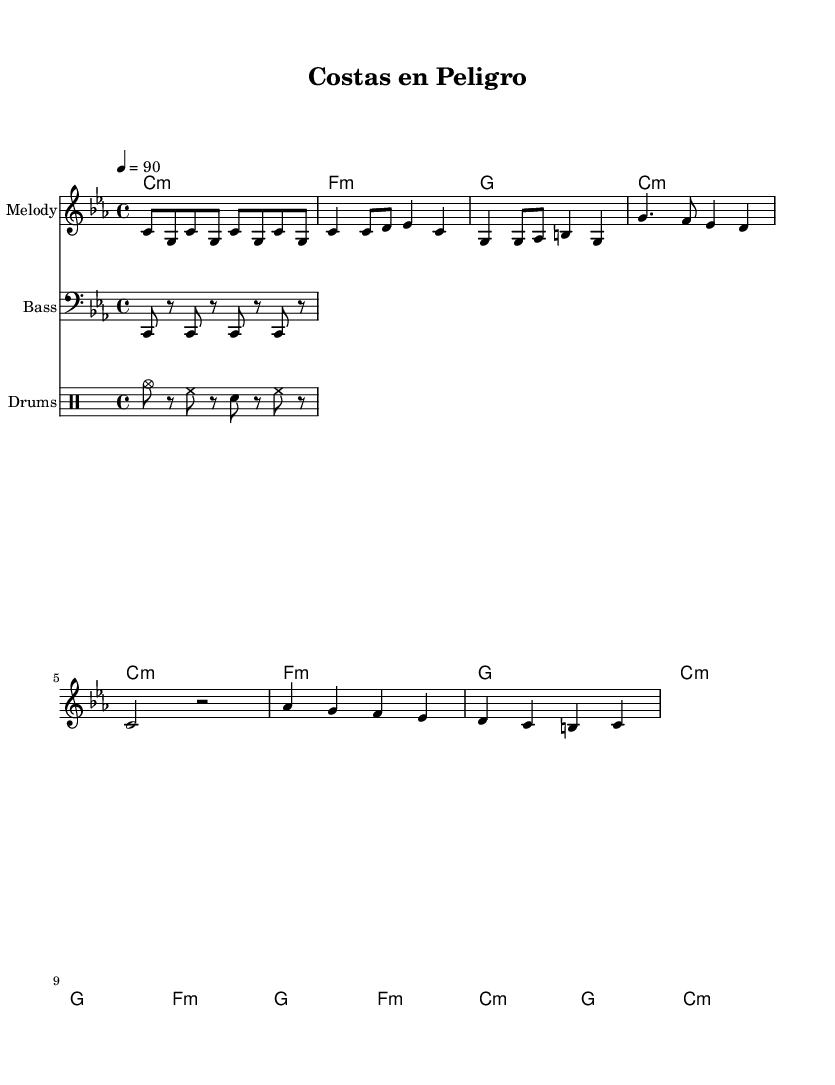What is the key signature of this music? The key signature is C minor, which includes three flats (B♭, E♭, and A♭). You can determine this by looking at the key signature at the beginning of the sheet music, which indicates the pitch and tonal center of the piece.
Answer: C minor What is the time signature of this music? The time signature is 4/4, as indicated at the beginning of the sheet music. This means there are four beats in each measure and the quarter note receives one beat.
Answer: 4/4 What is the tempo marking for this piece? The tempo marking is 90 beats per minute, which is indicated at the beginning of the sheet music. This tells the musician how fast to play the piece.
Answer: 90 How many measures are in the chorus section? The chorus section consists of 4 measures. You can identify measures by counting the number of vertical lines separating the music in that section.
Answer: 4 What type of percussion pattern is used in the drum section? The percussion pattern primarily features a hi-hat and snare with occasional cymbals. This can be observed in the drum notation, where specific symbols correspond to these instruments.
Answer: Hi-hat and snare What is the structure of the piece? The structure of the piece includes an Intro, Verse, Chorus, and Bridge. You can determine this by looking at the layout of the music and the titles above each section.
Answer: Intro, Verse, Chorus, Bridge What is the overall theme of the lyrics likely to address? The overall theme likely addresses environmental issues affecting coastal communities, based on the title "Costas en Peligro" and the context of the rap genre. This thematic content is usually conveyed through the lyrics that would accompany this sheet music.
Answer: Environmental issues 